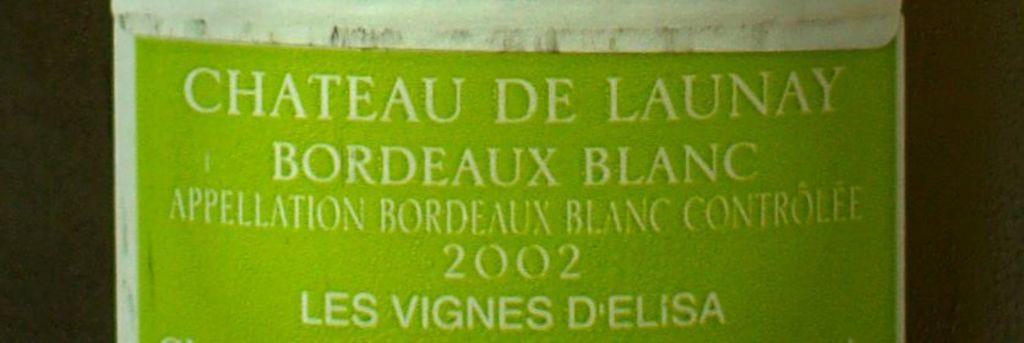<image>
Present a compact description of the photo's key features. The name Chateau De Launa is a French Bordeaux. 